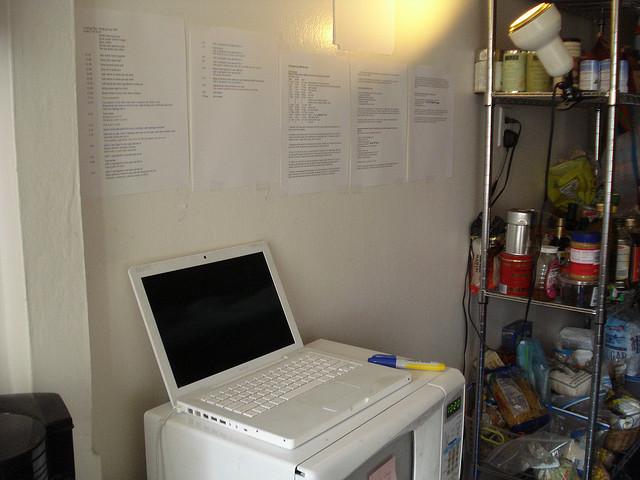What is posted to the wall?
Write a very short answer. Papers. Do you see any bananas?
Be succinct. No. What is the laptop sitting on?
Write a very short answer. Microwave. 